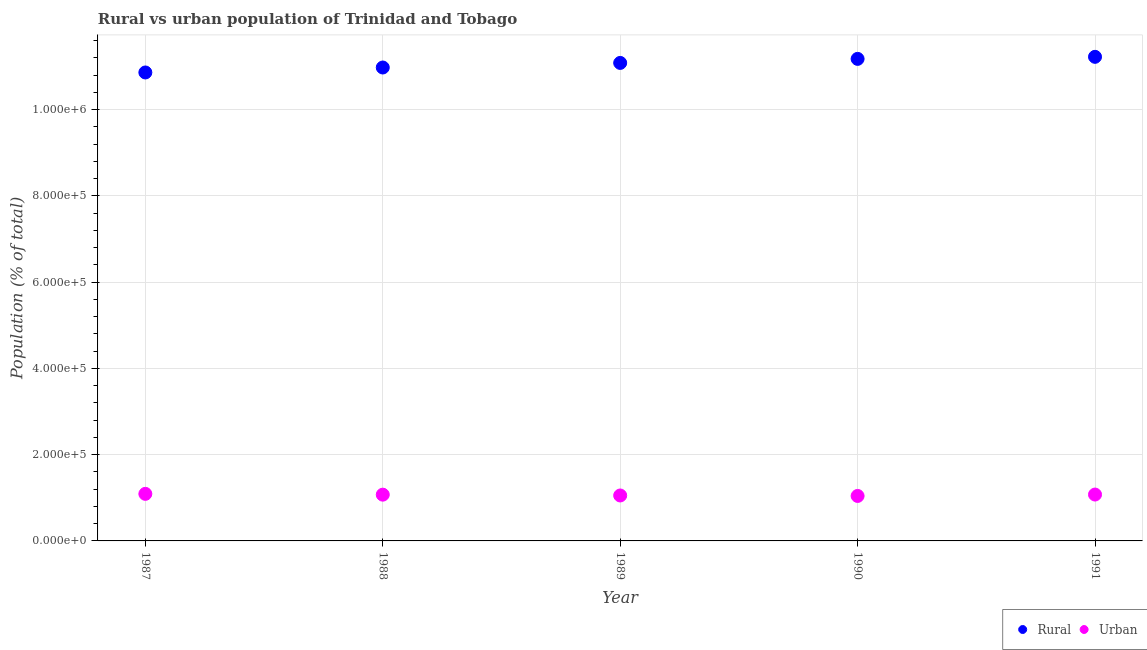Is the number of dotlines equal to the number of legend labels?
Ensure brevity in your answer.  Yes. What is the rural population density in 1991?
Make the answer very short. 1.12e+06. Across all years, what is the maximum urban population density?
Your response must be concise. 1.09e+05. Across all years, what is the minimum rural population density?
Provide a short and direct response. 1.09e+06. In which year was the urban population density maximum?
Give a very brief answer. 1987. What is the total rural population density in the graph?
Make the answer very short. 5.53e+06. What is the difference between the urban population density in 1988 and that in 1989?
Ensure brevity in your answer.  1904. What is the difference between the rural population density in 1989 and the urban population density in 1991?
Provide a succinct answer. 1.00e+06. What is the average urban population density per year?
Offer a very short reply. 1.07e+05. In the year 1990, what is the difference between the urban population density and rural population density?
Your response must be concise. -1.01e+06. In how many years, is the rural population density greater than 1080000 %?
Make the answer very short. 5. What is the ratio of the urban population density in 1987 to that in 1991?
Provide a short and direct response. 1.01. Is the rural population density in 1987 less than that in 1989?
Your answer should be very brief. Yes. Is the difference between the rural population density in 1988 and 1990 greater than the difference between the urban population density in 1988 and 1990?
Provide a succinct answer. No. What is the difference between the highest and the second highest urban population density?
Your answer should be compact. 1596. What is the difference between the highest and the lowest urban population density?
Provide a short and direct response. 4837. In how many years, is the urban population density greater than the average urban population density taken over all years?
Make the answer very short. 3. Is the sum of the rural population density in 1987 and 1988 greater than the maximum urban population density across all years?
Offer a very short reply. Yes. What is the difference between two consecutive major ticks on the Y-axis?
Offer a terse response. 2.00e+05. Does the graph contain any zero values?
Give a very brief answer. No. How are the legend labels stacked?
Offer a terse response. Horizontal. What is the title of the graph?
Give a very brief answer. Rural vs urban population of Trinidad and Tobago. Does "Register a business" appear as one of the legend labels in the graph?
Your response must be concise. No. What is the label or title of the X-axis?
Offer a very short reply. Year. What is the label or title of the Y-axis?
Ensure brevity in your answer.  Population (% of total). What is the Population (% of total) of Rural in 1987?
Offer a very short reply. 1.09e+06. What is the Population (% of total) in Urban in 1987?
Your response must be concise. 1.09e+05. What is the Population (% of total) of Rural in 1988?
Provide a succinct answer. 1.10e+06. What is the Population (% of total) in Urban in 1988?
Give a very brief answer. 1.07e+05. What is the Population (% of total) in Rural in 1989?
Keep it short and to the point. 1.11e+06. What is the Population (% of total) of Urban in 1989?
Ensure brevity in your answer.  1.05e+05. What is the Population (% of total) of Rural in 1990?
Keep it short and to the point. 1.12e+06. What is the Population (% of total) in Urban in 1990?
Your response must be concise. 1.04e+05. What is the Population (% of total) in Rural in 1991?
Offer a terse response. 1.12e+06. What is the Population (% of total) in Urban in 1991?
Give a very brief answer. 1.08e+05. Across all years, what is the maximum Population (% of total) of Rural?
Make the answer very short. 1.12e+06. Across all years, what is the maximum Population (% of total) in Urban?
Your answer should be very brief. 1.09e+05. Across all years, what is the minimum Population (% of total) of Rural?
Ensure brevity in your answer.  1.09e+06. Across all years, what is the minimum Population (% of total) of Urban?
Provide a short and direct response. 1.04e+05. What is the total Population (% of total) in Rural in the graph?
Provide a succinct answer. 5.53e+06. What is the total Population (% of total) of Urban in the graph?
Your response must be concise. 5.34e+05. What is the difference between the Population (% of total) in Rural in 1987 and that in 1988?
Provide a succinct answer. -1.15e+04. What is the difference between the Population (% of total) in Urban in 1987 and that in 1988?
Give a very brief answer. 1855. What is the difference between the Population (% of total) in Rural in 1987 and that in 1989?
Offer a very short reply. -2.21e+04. What is the difference between the Population (% of total) in Urban in 1987 and that in 1989?
Provide a short and direct response. 3759. What is the difference between the Population (% of total) in Rural in 1987 and that in 1990?
Offer a very short reply. -3.15e+04. What is the difference between the Population (% of total) of Urban in 1987 and that in 1990?
Keep it short and to the point. 4837. What is the difference between the Population (% of total) of Rural in 1987 and that in 1991?
Make the answer very short. -3.63e+04. What is the difference between the Population (% of total) in Urban in 1987 and that in 1991?
Offer a very short reply. 1596. What is the difference between the Population (% of total) of Rural in 1988 and that in 1989?
Provide a short and direct response. -1.06e+04. What is the difference between the Population (% of total) in Urban in 1988 and that in 1989?
Make the answer very short. 1904. What is the difference between the Population (% of total) of Rural in 1988 and that in 1990?
Your response must be concise. -2.00e+04. What is the difference between the Population (% of total) in Urban in 1988 and that in 1990?
Your response must be concise. 2982. What is the difference between the Population (% of total) in Rural in 1988 and that in 1991?
Offer a terse response. -2.48e+04. What is the difference between the Population (% of total) of Urban in 1988 and that in 1991?
Make the answer very short. -259. What is the difference between the Population (% of total) of Rural in 1989 and that in 1990?
Provide a short and direct response. -9357. What is the difference between the Population (% of total) of Urban in 1989 and that in 1990?
Offer a terse response. 1078. What is the difference between the Population (% of total) of Rural in 1989 and that in 1991?
Offer a terse response. -1.41e+04. What is the difference between the Population (% of total) of Urban in 1989 and that in 1991?
Provide a succinct answer. -2163. What is the difference between the Population (% of total) of Rural in 1990 and that in 1991?
Your answer should be compact. -4761. What is the difference between the Population (% of total) in Urban in 1990 and that in 1991?
Keep it short and to the point. -3241. What is the difference between the Population (% of total) of Rural in 1987 and the Population (% of total) of Urban in 1988?
Your answer should be very brief. 9.79e+05. What is the difference between the Population (% of total) of Rural in 1987 and the Population (% of total) of Urban in 1989?
Ensure brevity in your answer.  9.81e+05. What is the difference between the Population (% of total) in Rural in 1987 and the Population (% of total) in Urban in 1990?
Provide a succinct answer. 9.82e+05. What is the difference between the Population (% of total) in Rural in 1987 and the Population (% of total) in Urban in 1991?
Give a very brief answer. 9.79e+05. What is the difference between the Population (% of total) of Rural in 1988 and the Population (% of total) of Urban in 1989?
Provide a succinct answer. 9.92e+05. What is the difference between the Population (% of total) of Rural in 1988 and the Population (% of total) of Urban in 1990?
Give a very brief answer. 9.93e+05. What is the difference between the Population (% of total) in Rural in 1988 and the Population (% of total) in Urban in 1991?
Provide a succinct answer. 9.90e+05. What is the difference between the Population (% of total) of Rural in 1989 and the Population (% of total) of Urban in 1990?
Make the answer very short. 1.00e+06. What is the difference between the Population (% of total) of Rural in 1989 and the Population (% of total) of Urban in 1991?
Your response must be concise. 1.00e+06. What is the difference between the Population (% of total) of Rural in 1990 and the Population (% of total) of Urban in 1991?
Make the answer very short. 1.01e+06. What is the average Population (% of total) of Rural per year?
Make the answer very short. 1.11e+06. What is the average Population (% of total) in Urban per year?
Offer a very short reply. 1.07e+05. In the year 1987, what is the difference between the Population (% of total) of Rural and Population (% of total) of Urban?
Offer a terse response. 9.77e+05. In the year 1988, what is the difference between the Population (% of total) of Rural and Population (% of total) of Urban?
Your answer should be compact. 9.90e+05. In the year 1989, what is the difference between the Population (% of total) of Rural and Population (% of total) of Urban?
Give a very brief answer. 1.00e+06. In the year 1990, what is the difference between the Population (% of total) in Rural and Population (% of total) in Urban?
Give a very brief answer. 1.01e+06. In the year 1991, what is the difference between the Population (% of total) in Rural and Population (% of total) in Urban?
Provide a succinct answer. 1.01e+06. What is the ratio of the Population (% of total) in Urban in 1987 to that in 1988?
Your answer should be very brief. 1.02. What is the ratio of the Population (% of total) in Rural in 1987 to that in 1989?
Make the answer very short. 0.98. What is the ratio of the Population (% of total) of Urban in 1987 to that in 1989?
Offer a terse response. 1.04. What is the ratio of the Population (% of total) of Rural in 1987 to that in 1990?
Ensure brevity in your answer.  0.97. What is the ratio of the Population (% of total) of Urban in 1987 to that in 1990?
Provide a succinct answer. 1.05. What is the ratio of the Population (% of total) of Urban in 1987 to that in 1991?
Ensure brevity in your answer.  1.01. What is the ratio of the Population (% of total) in Urban in 1988 to that in 1989?
Keep it short and to the point. 1.02. What is the ratio of the Population (% of total) of Rural in 1988 to that in 1990?
Offer a very short reply. 0.98. What is the ratio of the Population (% of total) in Urban in 1988 to that in 1990?
Give a very brief answer. 1.03. What is the ratio of the Population (% of total) of Rural in 1988 to that in 1991?
Offer a terse response. 0.98. What is the ratio of the Population (% of total) of Urban in 1988 to that in 1991?
Offer a terse response. 1. What is the ratio of the Population (% of total) of Rural in 1989 to that in 1990?
Offer a very short reply. 0.99. What is the ratio of the Population (% of total) of Urban in 1989 to that in 1990?
Offer a terse response. 1.01. What is the ratio of the Population (% of total) of Rural in 1989 to that in 1991?
Keep it short and to the point. 0.99. What is the ratio of the Population (% of total) in Urban in 1989 to that in 1991?
Make the answer very short. 0.98. What is the ratio of the Population (% of total) in Urban in 1990 to that in 1991?
Offer a terse response. 0.97. What is the difference between the highest and the second highest Population (% of total) of Rural?
Your answer should be very brief. 4761. What is the difference between the highest and the second highest Population (% of total) in Urban?
Your answer should be compact. 1596. What is the difference between the highest and the lowest Population (% of total) of Rural?
Your response must be concise. 3.63e+04. What is the difference between the highest and the lowest Population (% of total) of Urban?
Make the answer very short. 4837. 